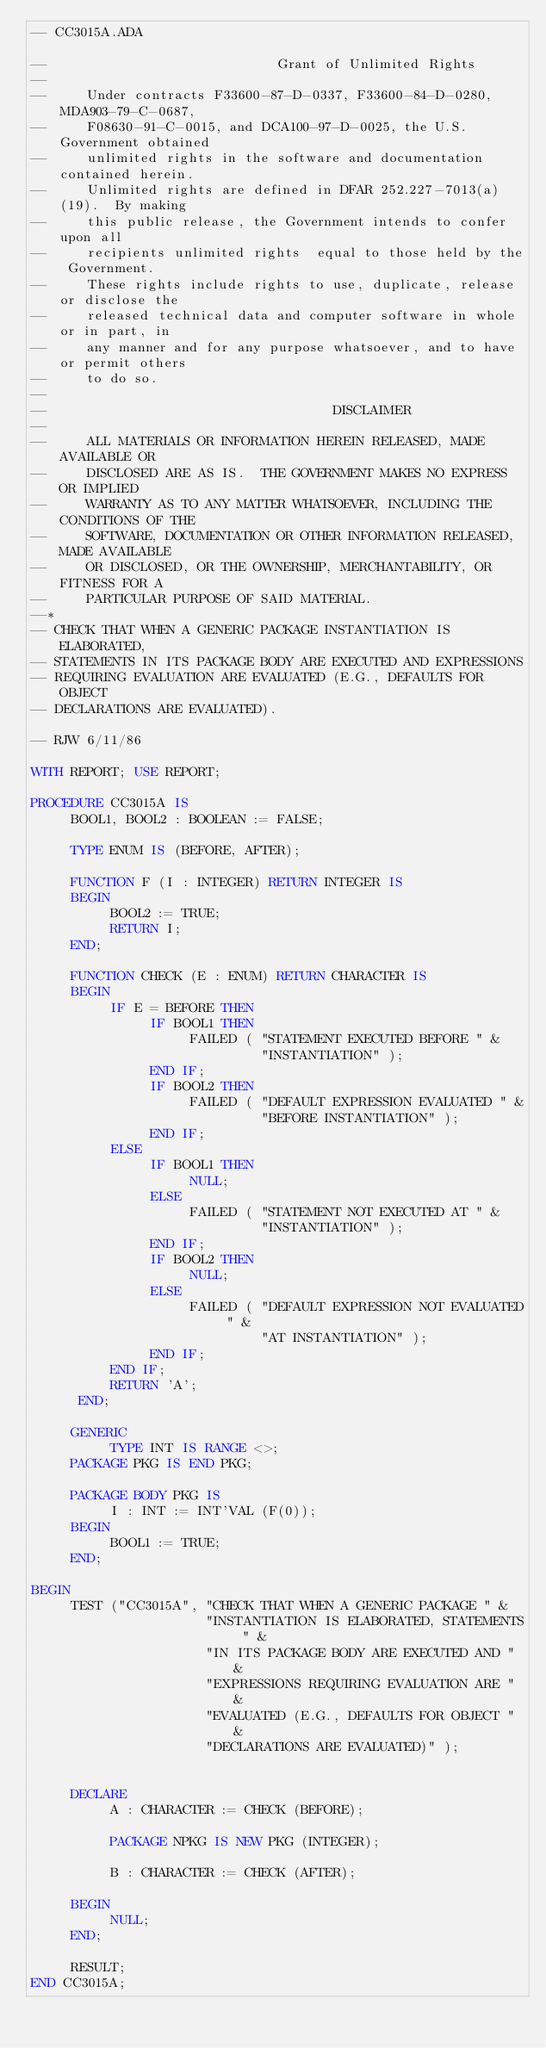<code> <loc_0><loc_0><loc_500><loc_500><_Ada_>-- CC3015A.ADA

--                             Grant of Unlimited Rights
--
--     Under contracts F33600-87-D-0337, F33600-84-D-0280, MDA903-79-C-0687,
--     F08630-91-C-0015, and DCA100-97-D-0025, the U.S. Government obtained 
--     unlimited rights in the software and documentation contained herein.
--     Unlimited rights are defined in DFAR 252.227-7013(a)(19).  By making 
--     this public release, the Government intends to confer upon all 
--     recipients unlimited rights  equal to those held by the Government.  
--     These rights include rights to use, duplicate, release or disclose the 
--     released technical data and computer software in whole or in part, in 
--     any manner and for any purpose whatsoever, and to have or permit others 
--     to do so.
--
--                                    DISCLAIMER
--
--     ALL MATERIALS OR INFORMATION HEREIN RELEASED, MADE AVAILABLE OR
--     DISCLOSED ARE AS IS.  THE GOVERNMENT MAKES NO EXPRESS OR IMPLIED 
--     WARRANTY AS TO ANY MATTER WHATSOEVER, INCLUDING THE CONDITIONS OF THE
--     SOFTWARE, DOCUMENTATION OR OTHER INFORMATION RELEASED, MADE AVAILABLE 
--     OR DISCLOSED, OR THE OWNERSHIP, MERCHANTABILITY, OR FITNESS FOR A
--     PARTICULAR PURPOSE OF SAID MATERIAL.
--*
-- CHECK THAT WHEN A GENERIC PACKAGE INSTANTIATION IS ELABORATED, 
-- STATEMENTS IN ITS PACKAGE BODY ARE EXECUTED AND EXPRESSIONS
-- REQUIRING EVALUATION ARE EVALUATED (E.G., DEFAULTS FOR OBJECT
-- DECLARATIONS ARE EVALUATED).

-- RJW 6/11/86

WITH REPORT; USE REPORT;

PROCEDURE CC3015A IS
     BOOL1, BOOL2 : BOOLEAN := FALSE;          
          
     TYPE ENUM IS (BEFORE, AFTER);

     FUNCTION F (I : INTEGER) RETURN INTEGER IS
     BEGIN
          BOOL2 := TRUE;
          RETURN I;
     END;
          
     FUNCTION CHECK (E : ENUM) RETURN CHARACTER IS
     BEGIN
          IF E = BEFORE THEN
               IF BOOL1 THEN
                    FAILED ( "STATEMENT EXECUTED BEFORE " &
                             "INSTANTIATION" );
               END IF;
               IF BOOL2 THEN
                    FAILED ( "DEFAULT EXPRESSION EVALUATED " &
                             "BEFORE INSTANTIATION" );
               END IF;
          ELSE
               IF BOOL1 THEN
                    NULL;
               ELSE
                    FAILED ( "STATEMENT NOT EXECUTED AT " &
                             "INSTANTIATION" );
               END IF;
               IF BOOL2 THEN
                    NULL;
               ELSE
                    FAILED ( "DEFAULT EXPRESSION NOT EVALUATED " &
                             "AT INSTANTIATION" );
               END IF;
          END IF;
          RETURN 'A';
      END;

     GENERIC 
          TYPE INT IS RANGE <>;
     PACKAGE PKG IS END PKG;

     PACKAGE BODY PKG IS
          I : INT := INT'VAL (F(0));
     BEGIN
          BOOL1 := TRUE;
     END;
                         
BEGIN
     TEST ("CC3015A", "CHECK THAT WHEN A GENERIC PACKAGE " & 
                      "INSTANTIATION IS ELABORATED, STATEMENTS " & 
                      "IN ITS PACKAGE BODY ARE EXECUTED AND " &
                      "EXPRESSIONS REQUIRING EVALUATION ARE " &
                      "EVALUATED (E.G., DEFAULTS FOR OBJECT " &
                      "DECLARATIONS ARE EVALUATED)" );
     

     DECLARE
          A : CHARACTER := CHECK (BEFORE);

          PACKAGE NPKG IS NEW PKG (INTEGER);
     
          B : CHARACTER := CHECK (AFTER);

     BEGIN
          NULL;
     END;          

     RESULT;
END CC3015A;
</code> 